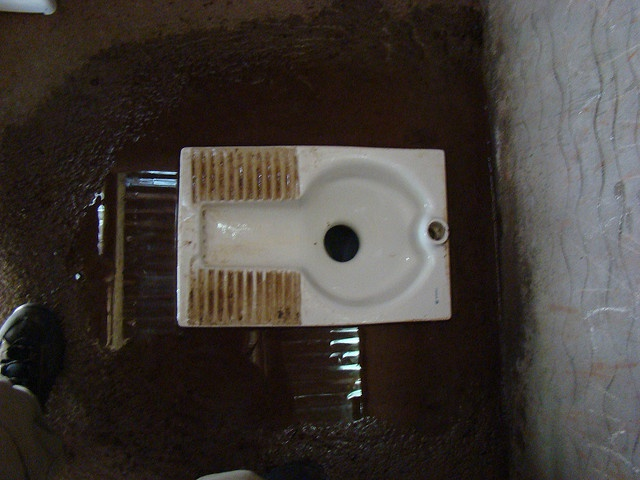Describe the objects in this image and their specific colors. I can see toilet in gray, darkgray, and olive tones and people in gray, black, darkgray, and navy tones in this image. 